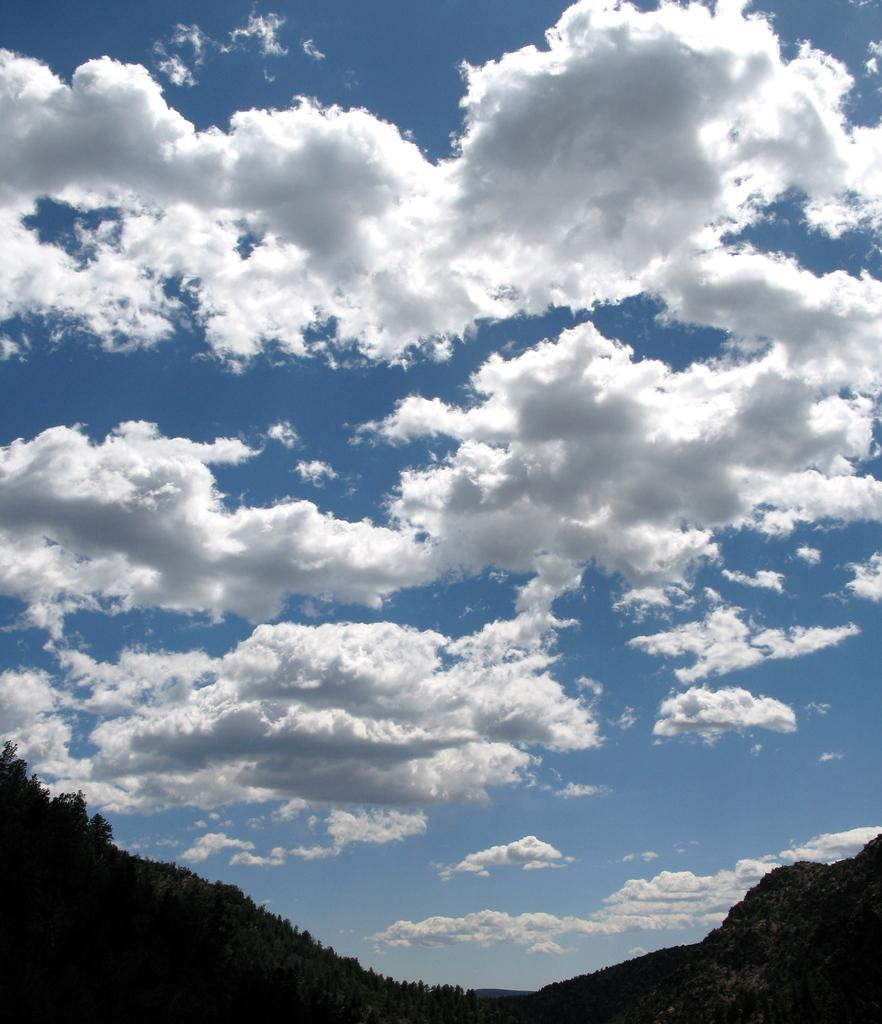What type of vegetation can be seen in the image? There are trees in the image. What can be seen in the sky in the image? There are clouds in the image. What is visible in the background of the image? The sky is visible in the image. What type of fork is being used to act in the image? There is no fork or act present in the image. 